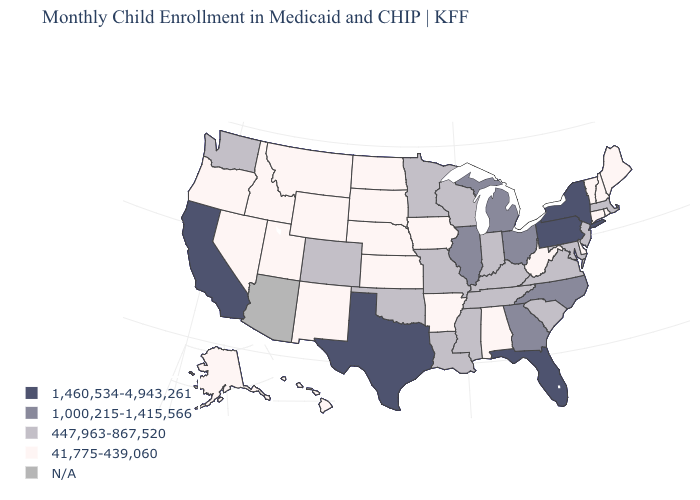What is the highest value in the West ?
Keep it brief. 1,460,534-4,943,261. Does the map have missing data?
Quick response, please. Yes. Name the states that have a value in the range 447,963-867,520?
Answer briefly. Colorado, Indiana, Kentucky, Louisiana, Maryland, Massachusetts, Minnesota, Mississippi, Missouri, New Jersey, Oklahoma, South Carolina, Tennessee, Virginia, Washington, Wisconsin. Which states hav the highest value in the MidWest?
Short answer required. Illinois, Michigan, Ohio. Does Hawaii have the highest value in the USA?
Write a very short answer. No. What is the lowest value in states that border Arizona?
Give a very brief answer. 41,775-439,060. Which states hav the highest value in the MidWest?
Give a very brief answer. Illinois, Michigan, Ohio. What is the value of Utah?
Give a very brief answer. 41,775-439,060. Which states have the lowest value in the MidWest?
Quick response, please. Iowa, Kansas, Nebraska, North Dakota, South Dakota. Name the states that have a value in the range 41,775-439,060?
Concise answer only. Alabama, Alaska, Arkansas, Connecticut, Delaware, Hawaii, Idaho, Iowa, Kansas, Maine, Montana, Nebraska, Nevada, New Hampshire, New Mexico, North Dakota, Oregon, Rhode Island, South Dakota, Utah, Vermont, West Virginia, Wyoming. What is the value of South Carolina?
Quick response, please. 447,963-867,520. Among the states that border Ohio , does Pennsylvania have the highest value?
Be succinct. Yes. What is the lowest value in the USA?
Answer briefly. 41,775-439,060. What is the value of New Hampshire?
Keep it brief. 41,775-439,060. What is the value of Kansas?
Be succinct. 41,775-439,060. 